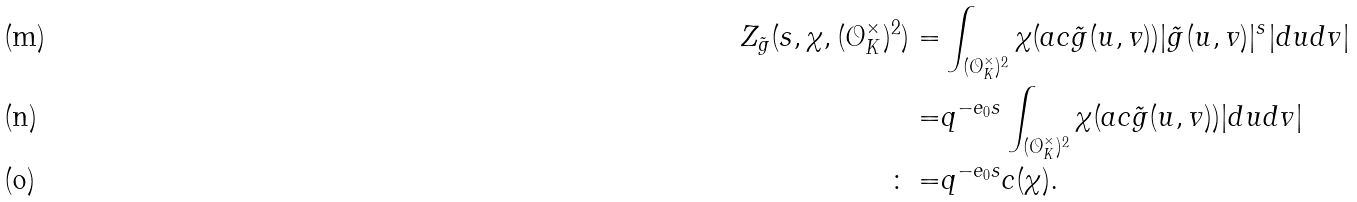Convert formula to latex. <formula><loc_0><loc_0><loc_500><loc_500>Z _ { \tilde { g } } ( s , \chi , ( \mathcal { O } _ { K } ^ { \times } ) ^ { 2 } ) = & \int _ { ( \mathcal { O } _ { K } ^ { \times } ) ^ { 2 } } \chi ( a c \tilde { g } ( u , v ) ) | \tilde { g } ( u , v ) | ^ { s } | d u d v | \\ = & q ^ { - e _ { 0 } s } \int _ { ( \mathcal { O } _ { K } ^ { \times } ) ^ { 2 } } \chi ( a c \tilde { g } ( u , v ) ) | d u d v | \\ \colon = & q ^ { - e _ { 0 } s } c ( \chi ) .</formula> 